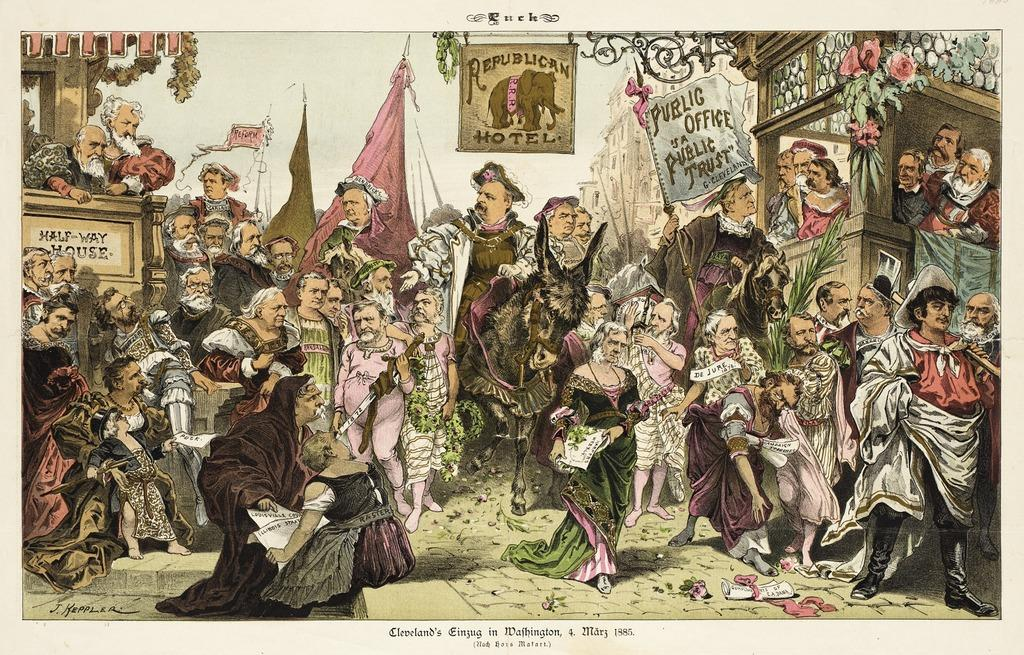<image>
Present a compact description of the photo's key features. A cartoon scene depicting many people beneath a sign reading Republican Motel. 